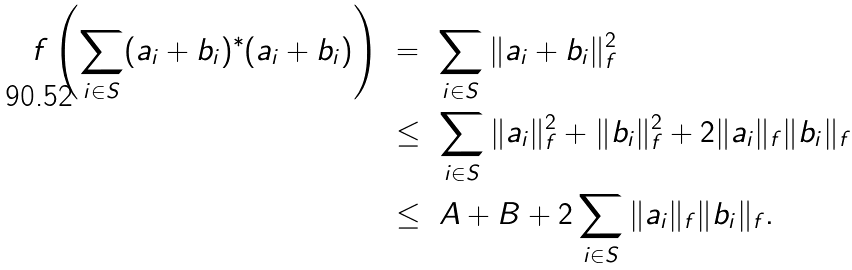Convert formula to latex. <formula><loc_0><loc_0><loc_500><loc_500>f \left ( \sum _ { i \in S } ( a _ { i } + b _ { i } ) ^ { * } ( a _ { i } + b _ { i } ) \right ) & \ = \ \sum _ { i \in S } \| a _ { i } + b _ { i } \| _ { f } ^ { 2 } \\ & \ \leq \ \sum _ { i \in S } \| a _ { i } \| _ { f } ^ { 2 } + \| b _ { i } \| _ { f } ^ { 2 } + 2 \| a _ { i } \| _ { f } \| b _ { i } \| _ { f } \\ & \ \leq \ A + B + 2 \sum _ { i \in S } \| a _ { i } \| _ { f } \| b _ { i } \| _ { f } .</formula> 